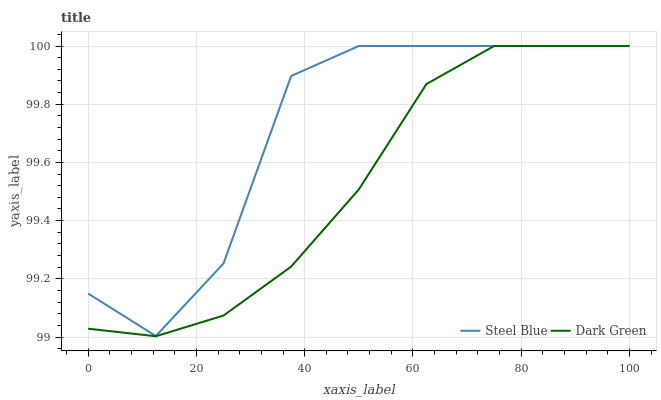Does Dark Green have the minimum area under the curve?
Answer yes or no. Yes. Does Steel Blue have the maximum area under the curve?
Answer yes or no. Yes. Does Dark Green have the maximum area under the curve?
Answer yes or no. No. Is Dark Green the smoothest?
Answer yes or no. Yes. Is Steel Blue the roughest?
Answer yes or no. Yes. Is Dark Green the roughest?
Answer yes or no. No. 